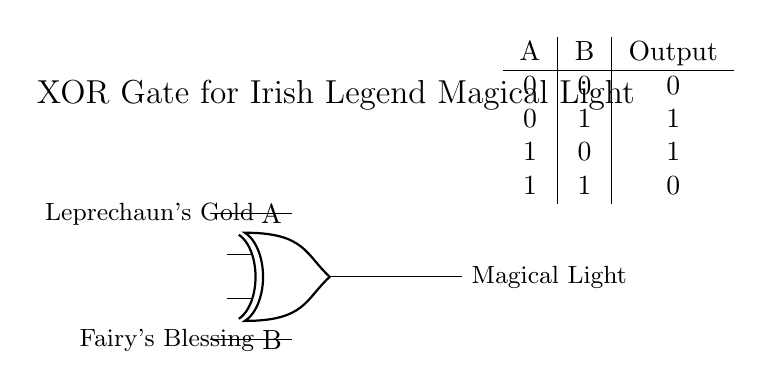What does the output represent? The output represents the "Magical Light," which is activated when the specific conditions are met according to Irish legends.
Answer: Magical Light How many inputs does the XOR gate have? The XOR gate has two inputs, labeled A and B in the diagram.
Answer: 2 What are the conditions that activate the light? The conditions are "Leprechaun's Gold" and "Fairy's Blessing," which activate the magical light when only one of them is present.
Answer: Leprechaun's Gold, Fairy's Blessing What happens to the output when both conditions are true? When both conditions are true (both inputs are 1), the output will be 0, indicating the light does not turn on.
Answer: 0 What is the role of the XOR gate in this circuit? The XOR gate determines when the magical light should be activated based on the presence of the two specific conditions, only illuminating when one is true.
Answer: Illumination Condition If Leprechaun's Gold is present and Fairy's Blessing is absent, what is the output? When Leprechaun's Gold is present (1) and Fairy's Blessing is absent (0), the output is 1, meaning the light will illuminate.
Answer: 1 What does it mean when both inputs are 0? When both inputs are 0 (neither condition is met), the output is also 0, meaning the light does not illuminate at all.
Answer: 0 